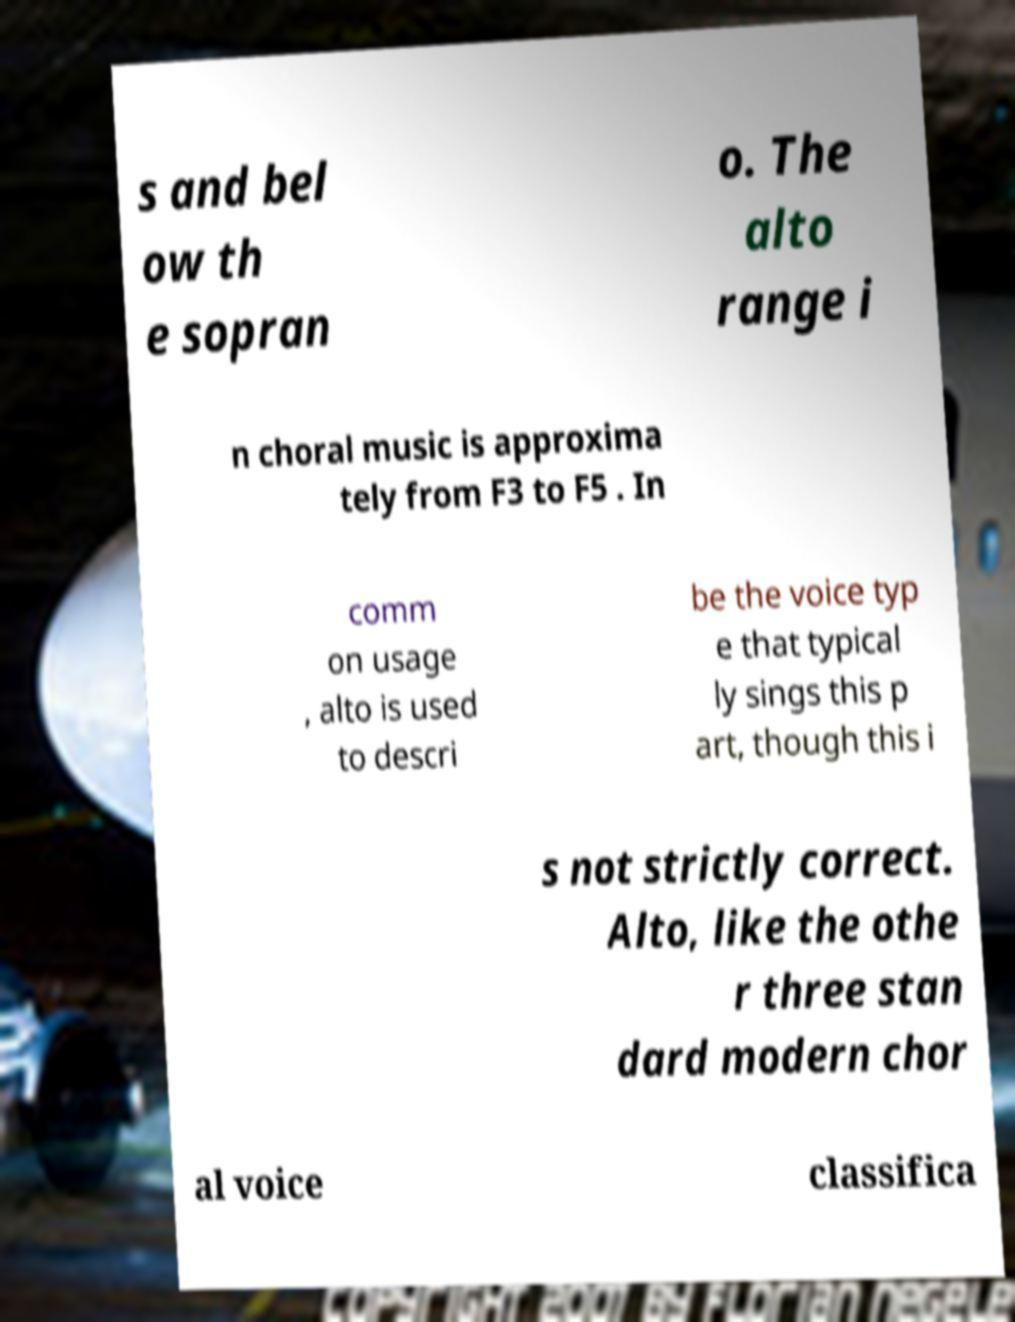Please identify and transcribe the text found in this image. s and bel ow th e sopran o. The alto range i n choral music is approxima tely from F3 to F5 . In comm on usage , alto is used to descri be the voice typ e that typical ly sings this p art, though this i s not strictly correct. Alto, like the othe r three stan dard modern chor al voice classifica 